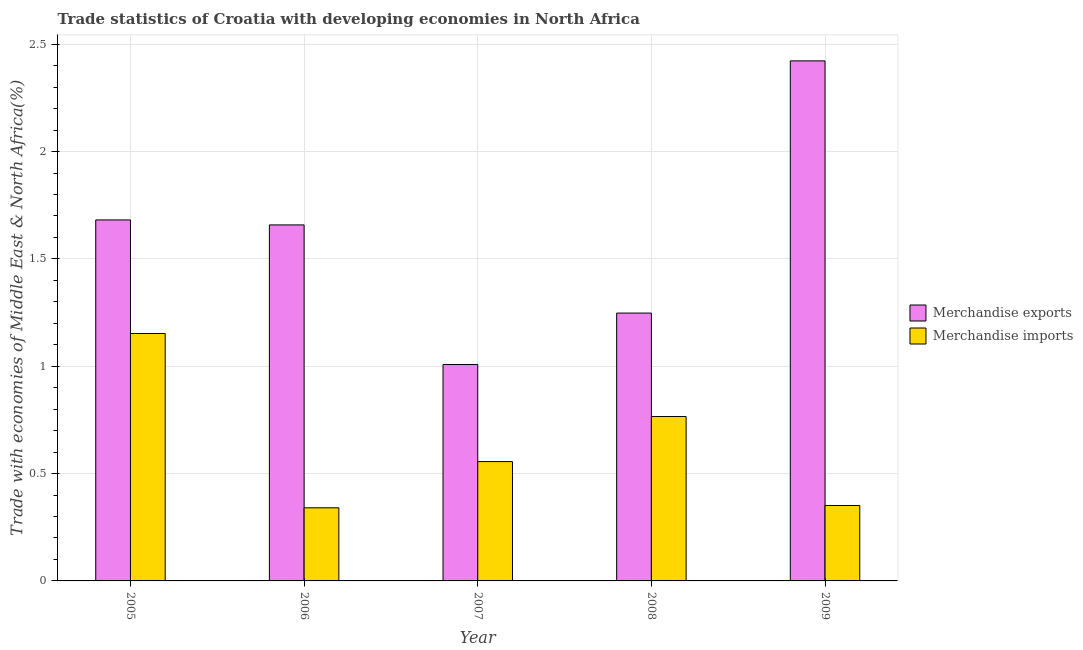How many different coloured bars are there?
Your answer should be very brief. 2. Are the number of bars per tick equal to the number of legend labels?
Offer a terse response. Yes. Are the number of bars on each tick of the X-axis equal?
Offer a very short reply. Yes. How many bars are there on the 2nd tick from the right?
Offer a terse response. 2. What is the label of the 2nd group of bars from the left?
Your answer should be compact. 2006. In how many cases, is the number of bars for a given year not equal to the number of legend labels?
Offer a very short reply. 0. What is the merchandise exports in 2006?
Make the answer very short. 1.66. Across all years, what is the maximum merchandise exports?
Keep it short and to the point. 2.42. Across all years, what is the minimum merchandise imports?
Your response must be concise. 0.34. In which year was the merchandise exports maximum?
Give a very brief answer. 2009. What is the total merchandise imports in the graph?
Provide a succinct answer. 3.17. What is the difference between the merchandise imports in 2005 and that in 2008?
Offer a terse response. 0.39. What is the difference between the merchandise imports in 2006 and the merchandise exports in 2008?
Your answer should be very brief. -0.43. What is the average merchandise imports per year?
Provide a succinct answer. 0.63. In how many years, is the merchandise imports greater than 1 %?
Offer a terse response. 1. What is the ratio of the merchandise exports in 2005 to that in 2006?
Keep it short and to the point. 1.01. Is the merchandise exports in 2006 less than that in 2008?
Make the answer very short. No. Is the difference between the merchandise imports in 2006 and 2007 greater than the difference between the merchandise exports in 2006 and 2007?
Offer a terse response. No. What is the difference between the highest and the second highest merchandise exports?
Your answer should be compact. 0.74. What is the difference between the highest and the lowest merchandise exports?
Provide a succinct answer. 1.41. What does the 2nd bar from the left in 2005 represents?
Your response must be concise. Merchandise imports. What does the 1st bar from the right in 2008 represents?
Your response must be concise. Merchandise imports. How many bars are there?
Your answer should be compact. 10. What is the difference between two consecutive major ticks on the Y-axis?
Give a very brief answer. 0.5. Are the values on the major ticks of Y-axis written in scientific E-notation?
Keep it short and to the point. No. Does the graph contain any zero values?
Provide a succinct answer. No. Where does the legend appear in the graph?
Ensure brevity in your answer.  Center right. How are the legend labels stacked?
Provide a succinct answer. Vertical. What is the title of the graph?
Offer a terse response. Trade statistics of Croatia with developing economies in North Africa. Does "Urban Population" appear as one of the legend labels in the graph?
Your answer should be compact. No. What is the label or title of the X-axis?
Your answer should be compact. Year. What is the label or title of the Y-axis?
Your answer should be very brief. Trade with economies of Middle East & North Africa(%). What is the Trade with economies of Middle East & North Africa(%) in Merchandise exports in 2005?
Keep it short and to the point. 1.68. What is the Trade with economies of Middle East & North Africa(%) in Merchandise imports in 2005?
Ensure brevity in your answer.  1.15. What is the Trade with economies of Middle East & North Africa(%) in Merchandise exports in 2006?
Give a very brief answer. 1.66. What is the Trade with economies of Middle East & North Africa(%) of Merchandise imports in 2006?
Make the answer very short. 0.34. What is the Trade with economies of Middle East & North Africa(%) of Merchandise exports in 2007?
Offer a very short reply. 1.01. What is the Trade with economies of Middle East & North Africa(%) of Merchandise imports in 2007?
Provide a succinct answer. 0.56. What is the Trade with economies of Middle East & North Africa(%) of Merchandise exports in 2008?
Offer a terse response. 1.25. What is the Trade with economies of Middle East & North Africa(%) in Merchandise imports in 2008?
Make the answer very short. 0.77. What is the Trade with economies of Middle East & North Africa(%) in Merchandise exports in 2009?
Your answer should be compact. 2.42. What is the Trade with economies of Middle East & North Africa(%) of Merchandise imports in 2009?
Your answer should be compact. 0.35. Across all years, what is the maximum Trade with economies of Middle East & North Africa(%) in Merchandise exports?
Ensure brevity in your answer.  2.42. Across all years, what is the maximum Trade with economies of Middle East & North Africa(%) of Merchandise imports?
Keep it short and to the point. 1.15. Across all years, what is the minimum Trade with economies of Middle East & North Africa(%) of Merchandise exports?
Offer a terse response. 1.01. Across all years, what is the minimum Trade with economies of Middle East & North Africa(%) in Merchandise imports?
Offer a very short reply. 0.34. What is the total Trade with economies of Middle East & North Africa(%) in Merchandise exports in the graph?
Keep it short and to the point. 8.02. What is the total Trade with economies of Middle East & North Africa(%) of Merchandise imports in the graph?
Provide a succinct answer. 3.17. What is the difference between the Trade with economies of Middle East & North Africa(%) in Merchandise exports in 2005 and that in 2006?
Give a very brief answer. 0.02. What is the difference between the Trade with economies of Middle East & North Africa(%) in Merchandise imports in 2005 and that in 2006?
Make the answer very short. 0.81. What is the difference between the Trade with economies of Middle East & North Africa(%) of Merchandise exports in 2005 and that in 2007?
Keep it short and to the point. 0.67. What is the difference between the Trade with economies of Middle East & North Africa(%) of Merchandise imports in 2005 and that in 2007?
Give a very brief answer. 0.6. What is the difference between the Trade with economies of Middle East & North Africa(%) in Merchandise exports in 2005 and that in 2008?
Offer a terse response. 0.43. What is the difference between the Trade with economies of Middle East & North Africa(%) of Merchandise imports in 2005 and that in 2008?
Your response must be concise. 0.39. What is the difference between the Trade with economies of Middle East & North Africa(%) of Merchandise exports in 2005 and that in 2009?
Give a very brief answer. -0.74. What is the difference between the Trade with economies of Middle East & North Africa(%) of Merchandise imports in 2005 and that in 2009?
Provide a short and direct response. 0.8. What is the difference between the Trade with economies of Middle East & North Africa(%) in Merchandise exports in 2006 and that in 2007?
Your answer should be very brief. 0.65. What is the difference between the Trade with economies of Middle East & North Africa(%) in Merchandise imports in 2006 and that in 2007?
Your response must be concise. -0.22. What is the difference between the Trade with economies of Middle East & North Africa(%) of Merchandise exports in 2006 and that in 2008?
Offer a terse response. 0.41. What is the difference between the Trade with economies of Middle East & North Africa(%) of Merchandise imports in 2006 and that in 2008?
Offer a terse response. -0.43. What is the difference between the Trade with economies of Middle East & North Africa(%) of Merchandise exports in 2006 and that in 2009?
Provide a short and direct response. -0.76. What is the difference between the Trade with economies of Middle East & North Africa(%) in Merchandise imports in 2006 and that in 2009?
Your answer should be compact. -0.01. What is the difference between the Trade with economies of Middle East & North Africa(%) in Merchandise exports in 2007 and that in 2008?
Offer a very short reply. -0.24. What is the difference between the Trade with economies of Middle East & North Africa(%) in Merchandise imports in 2007 and that in 2008?
Your answer should be compact. -0.21. What is the difference between the Trade with economies of Middle East & North Africa(%) in Merchandise exports in 2007 and that in 2009?
Make the answer very short. -1.41. What is the difference between the Trade with economies of Middle East & North Africa(%) in Merchandise imports in 2007 and that in 2009?
Offer a very short reply. 0.2. What is the difference between the Trade with economies of Middle East & North Africa(%) in Merchandise exports in 2008 and that in 2009?
Ensure brevity in your answer.  -1.17. What is the difference between the Trade with economies of Middle East & North Africa(%) in Merchandise imports in 2008 and that in 2009?
Provide a succinct answer. 0.41. What is the difference between the Trade with economies of Middle East & North Africa(%) in Merchandise exports in 2005 and the Trade with economies of Middle East & North Africa(%) in Merchandise imports in 2006?
Provide a short and direct response. 1.34. What is the difference between the Trade with economies of Middle East & North Africa(%) of Merchandise exports in 2005 and the Trade with economies of Middle East & North Africa(%) of Merchandise imports in 2007?
Provide a short and direct response. 1.13. What is the difference between the Trade with economies of Middle East & North Africa(%) of Merchandise exports in 2005 and the Trade with economies of Middle East & North Africa(%) of Merchandise imports in 2008?
Offer a very short reply. 0.92. What is the difference between the Trade with economies of Middle East & North Africa(%) in Merchandise exports in 2005 and the Trade with economies of Middle East & North Africa(%) in Merchandise imports in 2009?
Offer a terse response. 1.33. What is the difference between the Trade with economies of Middle East & North Africa(%) of Merchandise exports in 2006 and the Trade with economies of Middle East & North Africa(%) of Merchandise imports in 2007?
Your answer should be very brief. 1.1. What is the difference between the Trade with economies of Middle East & North Africa(%) in Merchandise exports in 2006 and the Trade with economies of Middle East & North Africa(%) in Merchandise imports in 2008?
Give a very brief answer. 0.89. What is the difference between the Trade with economies of Middle East & North Africa(%) in Merchandise exports in 2006 and the Trade with economies of Middle East & North Africa(%) in Merchandise imports in 2009?
Your answer should be compact. 1.31. What is the difference between the Trade with economies of Middle East & North Africa(%) of Merchandise exports in 2007 and the Trade with economies of Middle East & North Africa(%) of Merchandise imports in 2008?
Your answer should be compact. 0.24. What is the difference between the Trade with economies of Middle East & North Africa(%) of Merchandise exports in 2007 and the Trade with economies of Middle East & North Africa(%) of Merchandise imports in 2009?
Your answer should be compact. 0.66. What is the difference between the Trade with economies of Middle East & North Africa(%) of Merchandise exports in 2008 and the Trade with economies of Middle East & North Africa(%) of Merchandise imports in 2009?
Provide a succinct answer. 0.9. What is the average Trade with economies of Middle East & North Africa(%) in Merchandise exports per year?
Your answer should be very brief. 1.6. What is the average Trade with economies of Middle East & North Africa(%) of Merchandise imports per year?
Give a very brief answer. 0.63. In the year 2005, what is the difference between the Trade with economies of Middle East & North Africa(%) in Merchandise exports and Trade with economies of Middle East & North Africa(%) in Merchandise imports?
Provide a short and direct response. 0.53. In the year 2006, what is the difference between the Trade with economies of Middle East & North Africa(%) of Merchandise exports and Trade with economies of Middle East & North Africa(%) of Merchandise imports?
Offer a very short reply. 1.32. In the year 2007, what is the difference between the Trade with economies of Middle East & North Africa(%) in Merchandise exports and Trade with economies of Middle East & North Africa(%) in Merchandise imports?
Your response must be concise. 0.45. In the year 2008, what is the difference between the Trade with economies of Middle East & North Africa(%) of Merchandise exports and Trade with economies of Middle East & North Africa(%) of Merchandise imports?
Offer a very short reply. 0.48. In the year 2009, what is the difference between the Trade with economies of Middle East & North Africa(%) in Merchandise exports and Trade with economies of Middle East & North Africa(%) in Merchandise imports?
Your answer should be very brief. 2.07. What is the ratio of the Trade with economies of Middle East & North Africa(%) of Merchandise imports in 2005 to that in 2006?
Keep it short and to the point. 3.38. What is the ratio of the Trade with economies of Middle East & North Africa(%) of Merchandise exports in 2005 to that in 2007?
Ensure brevity in your answer.  1.67. What is the ratio of the Trade with economies of Middle East & North Africa(%) of Merchandise imports in 2005 to that in 2007?
Provide a succinct answer. 2.07. What is the ratio of the Trade with economies of Middle East & North Africa(%) of Merchandise exports in 2005 to that in 2008?
Your answer should be very brief. 1.35. What is the ratio of the Trade with economies of Middle East & North Africa(%) of Merchandise imports in 2005 to that in 2008?
Provide a succinct answer. 1.51. What is the ratio of the Trade with economies of Middle East & North Africa(%) in Merchandise exports in 2005 to that in 2009?
Make the answer very short. 0.69. What is the ratio of the Trade with economies of Middle East & North Africa(%) of Merchandise imports in 2005 to that in 2009?
Give a very brief answer. 3.28. What is the ratio of the Trade with economies of Middle East & North Africa(%) in Merchandise exports in 2006 to that in 2007?
Give a very brief answer. 1.65. What is the ratio of the Trade with economies of Middle East & North Africa(%) in Merchandise imports in 2006 to that in 2007?
Offer a very short reply. 0.61. What is the ratio of the Trade with economies of Middle East & North Africa(%) of Merchandise exports in 2006 to that in 2008?
Your answer should be very brief. 1.33. What is the ratio of the Trade with economies of Middle East & North Africa(%) of Merchandise imports in 2006 to that in 2008?
Make the answer very short. 0.44. What is the ratio of the Trade with economies of Middle East & North Africa(%) of Merchandise exports in 2006 to that in 2009?
Your answer should be very brief. 0.68. What is the ratio of the Trade with economies of Middle East & North Africa(%) of Merchandise imports in 2006 to that in 2009?
Ensure brevity in your answer.  0.97. What is the ratio of the Trade with economies of Middle East & North Africa(%) in Merchandise exports in 2007 to that in 2008?
Provide a succinct answer. 0.81. What is the ratio of the Trade with economies of Middle East & North Africa(%) of Merchandise imports in 2007 to that in 2008?
Your answer should be compact. 0.73. What is the ratio of the Trade with economies of Middle East & North Africa(%) in Merchandise exports in 2007 to that in 2009?
Your answer should be very brief. 0.42. What is the ratio of the Trade with economies of Middle East & North Africa(%) in Merchandise imports in 2007 to that in 2009?
Ensure brevity in your answer.  1.58. What is the ratio of the Trade with economies of Middle East & North Africa(%) of Merchandise exports in 2008 to that in 2009?
Offer a very short reply. 0.52. What is the ratio of the Trade with economies of Middle East & North Africa(%) in Merchandise imports in 2008 to that in 2009?
Provide a short and direct response. 2.18. What is the difference between the highest and the second highest Trade with economies of Middle East & North Africa(%) in Merchandise exports?
Your answer should be very brief. 0.74. What is the difference between the highest and the second highest Trade with economies of Middle East & North Africa(%) of Merchandise imports?
Ensure brevity in your answer.  0.39. What is the difference between the highest and the lowest Trade with economies of Middle East & North Africa(%) of Merchandise exports?
Your response must be concise. 1.41. What is the difference between the highest and the lowest Trade with economies of Middle East & North Africa(%) in Merchandise imports?
Offer a very short reply. 0.81. 